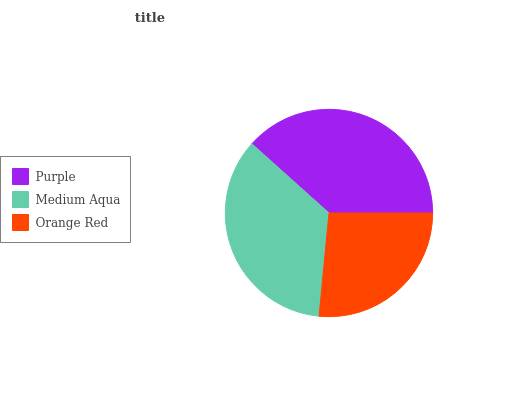Is Orange Red the minimum?
Answer yes or no. Yes. Is Purple the maximum?
Answer yes or no. Yes. Is Medium Aqua the minimum?
Answer yes or no. No. Is Medium Aqua the maximum?
Answer yes or no. No. Is Purple greater than Medium Aqua?
Answer yes or no. Yes. Is Medium Aqua less than Purple?
Answer yes or no. Yes. Is Medium Aqua greater than Purple?
Answer yes or no. No. Is Purple less than Medium Aqua?
Answer yes or no. No. Is Medium Aqua the high median?
Answer yes or no. Yes. Is Medium Aqua the low median?
Answer yes or no. Yes. Is Orange Red the high median?
Answer yes or no. No. Is Purple the low median?
Answer yes or no. No. 